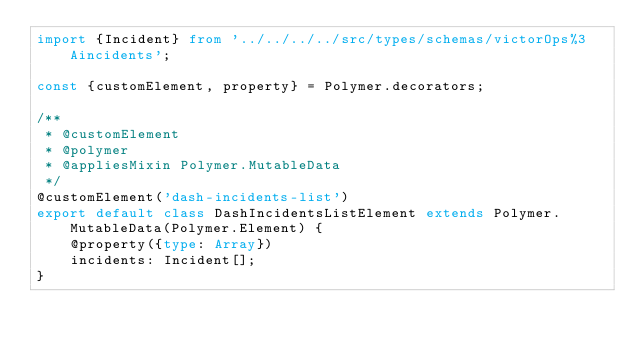<code> <loc_0><loc_0><loc_500><loc_500><_TypeScript_>import {Incident} from '../../../../src/types/schemas/victorOps%3Aincidents';

const {customElement, property} = Polymer.decorators;

/**
 * @customElement
 * @polymer
 * @appliesMixin Polymer.MutableData
 */
@customElement('dash-incidents-list')
export default class DashIncidentsListElement extends Polymer.MutableData(Polymer.Element) {
	@property({type: Array})
	incidents: Incident[];
}
</code> 